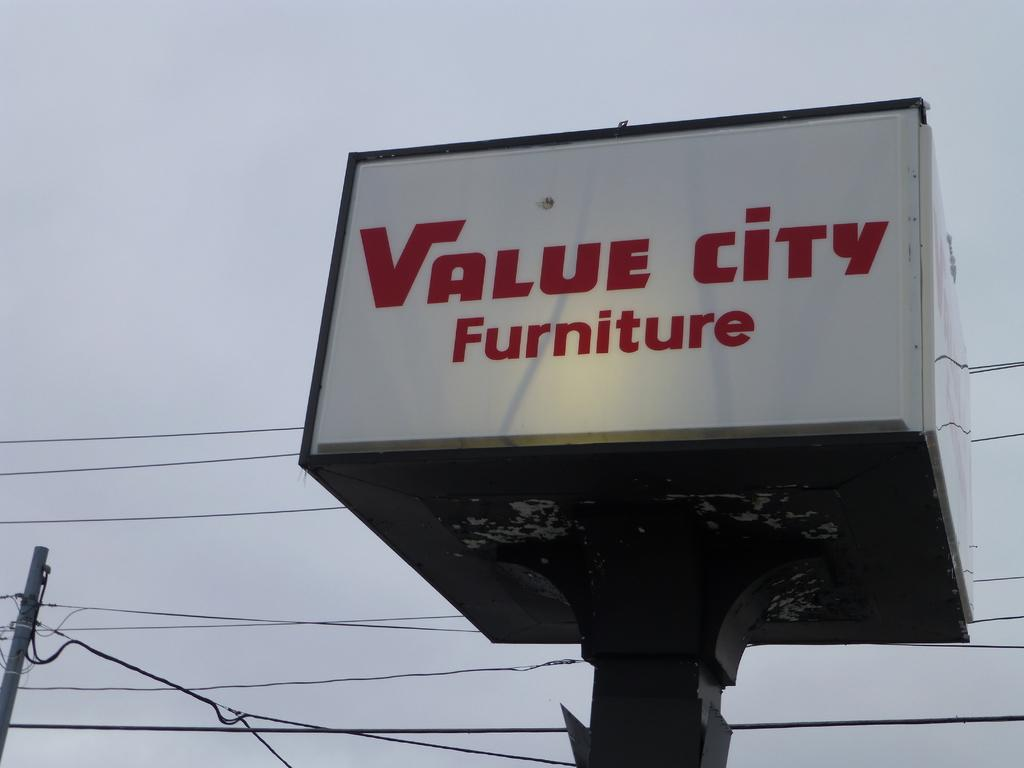Provide a one-sentence caption for the provided image. A large cube shaped sign for Value city furniture has a single spotlight aimed at it. 